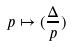Convert formula to latex. <formula><loc_0><loc_0><loc_500><loc_500>p \mapsto ( \frac { \Delta } { p } )</formula> 